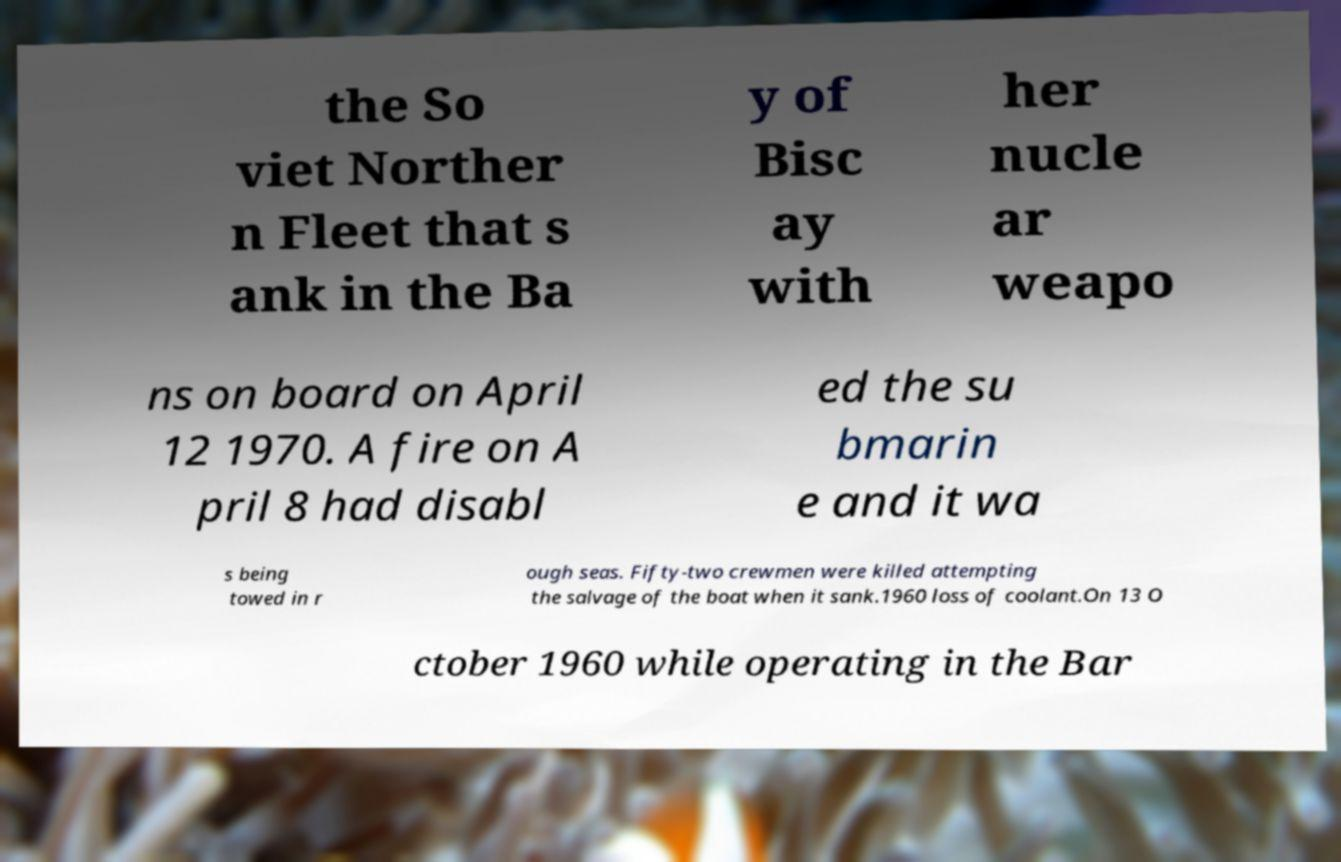Can you read and provide the text displayed in the image?This photo seems to have some interesting text. Can you extract and type it out for me? the So viet Norther n Fleet that s ank in the Ba y of Bisc ay with her nucle ar weapo ns on board on April 12 1970. A fire on A pril 8 had disabl ed the su bmarin e and it wa s being towed in r ough seas. Fifty-two crewmen were killed attempting the salvage of the boat when it sank.1960 loss of coolant.On 13 O ctober 1960 while operating in the Bar 